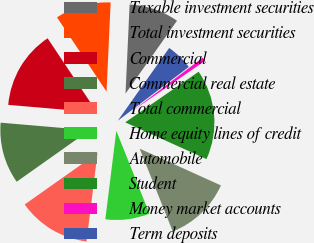Convert chart. <chart><loc_0><loc_0><loc_500><loc_500><pie_chart><fcel>Taxable investment securities<fcel>Total investment securities<fcel>Commercial<fcel>Commercial real estate<fcel>Total commercial<fcel>Home equity lines of credit<fcel>Automobile<fcel>Student<fcel>Money market accounts<fcel>Term deposits<nl><fcel>9.06%<fcel>10.1%<fcel>14.28%<fcel>11.15%<fcel>13.24%<fcel>8.02%<fcel>12.19%<fcel>16.37%<fcel>0.71%<fcel>4.89%<nl></chart> 